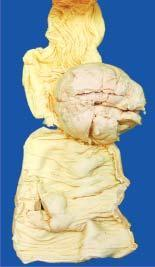s the covering mucosa ulcerated?
Answer the question using a single word or phrase. Yes 